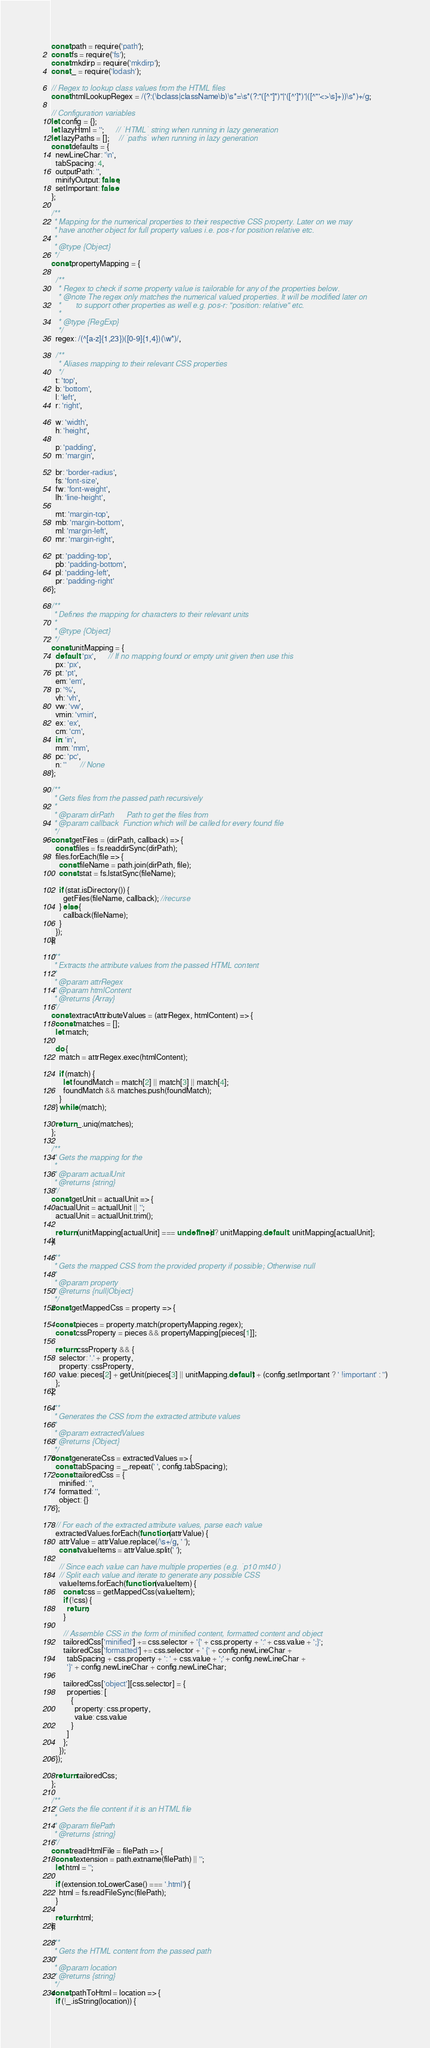Convert code to text. <code><loc_0><loc_0><loc_500><loc_500><_JavaScript_>const path = require('path');
const fs = require('fs');
const mkdirp = require('mkdirp');
const _ = require('lodash');

// Regex to lookup class values from the HTML files
const htmlLookupRegex = /(?:(\bclass|className\b)\s*=\s*(?:"([^"]*)"|'([^']*)'|([^"'<>\s]+))\s*)+/g;

// Configuration variables
let config = {};
let lazyHtml = '';      // `HTML` string when running in lazy generation
let lazyPaths = [];     // `paths` when running in lazy generation
const defaults = {
  newLineChar: '\n',
  tabSpacing: 4,
  outputPath: '',
  minifyOutput: false,
  setImportant: false
};

/**
 * Mapping for the numerical properties to their respective CSS property. Later on we may
 * have another object for full property values i.e. pos-r for position relative etc.
 *
 * @type {Object}
 */
const propertyMapping = {

  /**
   * Regex to check if some property value is tailorable for any of the properties below.
   * @note The regex only matches the numerical valued properties. It will be modified later on
   *       to support other properties as well e.g. pos-r: "position: relative" etc.
   *
   * @type {RegExp}
   */
  regex: /(^[a-z]{1,23})([0-9]{1,4})(\w*)/,

  /**
   * Aliases mapping to their relevant CSS properties
   */
  t: 'top',
  b: 'bottom',
  l: 'left',
  r: 'right',

  w: 'width',
  h: 'height',

  p: 'padding',
  m: 'margin',

  br: 'border-radius',
  fs: 'font-size',
  fw: 'font-weight',
  lh: 'line-height',

  mt: 'margin-top',
  mb: 'margin-bottom',
  ml: 'margin-left',
  mr: 'margin-right',

  pt: 'padding-top',
  pb: 'padding-bottom',
  pl: 'padding-left',
  pr: 'padding-right'
};

/**
 * Defines the mapping for characters to their relevant units
 *
 * @type {Object}
 */
const unitMapping = {
  default: 'px',      // If no mapping found or empty unit given then use this
  px: 'px',
  pt: 'pt',
  em: 'em',
  p: '%',
  vh: 'vh',
  vw: 'vw',
  vmin: 'vmin',
  ex: 'ex',
  cm: 'cm',
  in: 'in',
  mm: 'mm',
  pc: 'pc',
  n: ''       // None
};

/**
 * Gets files from the passed path recursively
 *
 * @param dirPath      Path to get the files from
 * @param callback  Function which will be called for every found file
 */
const getFiles = (dirPath, callback) => {
  const files = fs.readdirSync(dirPath);
  files.forEach(file => {
    const fileName = path.join(dirPath, file);
    const stat = fs.lstatSync(fileName);

    if (stat.isDirectory()) {
      getFiles(fileName, callback); //recurse
    } else {
      callback(fileName);
    }
  });
};

/**
 * Extracts the attribute values from the passed HTML content
 *
 * @param attrRegex
 * @param htmlContent
 * @returns {Array}
 */
const extractAttributeValues = (attrRegex, htmlContent) => {
  const matches = [];
  let match;

  do {
    match = attrRegex.exec(htmlContent);

    if (match) {
      let foundMatch = match[2] || match[3] || match[4];
      foundMatch && matches.push(foundMatch);
    }
  } while (match);

  return _.uniq(matches);
};

/**
 * Gets the mapping for the
 *
 * @param actualUnit
 * @returns {string}
 */
const getUnit = actualUnit => {
  actualUnit = actualUnit || '';
  actualUnit = actualUnit.trim();

  return (unitMapping[actualUnit] === undefined) ? unitMapping.default : unitMapping[actualUnit];
};

/**
 * Gets the mapped CSS from the provided property if possible; Otherwise null
 *
 * @param property
 * @returns {null|Object}
 */
const getMappedCss = property => {

  const pieces = property.match(propertyMapping.regex);
  const cssProperty = pieces && propertyMapping[pieces[1]];

  return cssProperty && {
    selector: '.' + property,
    property: cssProperty,
    value: pieces[2] + getUnit(pieces[3] || unitMapping.default) + (config.setImportant ? ' !important' : '')
  };
};

/**
 * Generates the CSS from the extracted attribute values
 *
 * @param extractedValues
 * @returns {Object}
 */
const generateCss = extractedValues => {
  const tabSpacing = _.repeat(' ', config.tabSpacing);
  const tailoredCss = {
    minified: '',
    formatted: '',
    object: {}
  };

  // For each of the extracted attribute values, parse each value
  extractedValues.forEach(function (attrValue) {
    attrValue = attrValue.replace(/\s+/g, ' ');
    const valueItems = attrValue.split(' ');

    // Since each value can have multiple properties (e.g. `p10 mt40`)
    // Split each value and iterate to generate any possible CSS
    valueItems.forEach(function (valueItem) {
      const css = getMappedCss(valueItem);
      if (!css) {
        return;
      }

      // Assemble CSS in the form of minified content, formatted content and object
      tailoredCss['minified'] += css.selector + '{' + css.property + ':' + css.value + ';}';
      tailoredCss['formatted'] += css.selector + ' {' + config.newLineChar +
        tabSpacing + css.property + ': ' + css.value + ';' + config.newLineChar +
        '}' + config.newLineChar + config.newLineChar;

      tailoredCss['object'][css.selector] = {
        properties: [
          {
            property: css.property,
            value: css.value
          }
        ]
      };
    });
  });

  return tailoredCss;
};

/**
 * Gets the file content if it is an HTML file
 *
 * @param filePath
 * @returns {string}
 */
const readHtmlFile = filePath => {
  const extension = path.extname(filePath) || '';
  let html = '';

  if (extension.toLowerCase() === '.html') {
    html = fs.readFileSync(filePath);
  }

  return html;
};

/**
 * Gets the HTML content from the passed path
 *
 * @param location
 * @returns {string}
 */
const pathToHtml = location => {
  if (!_.isString(location)) {</code> 